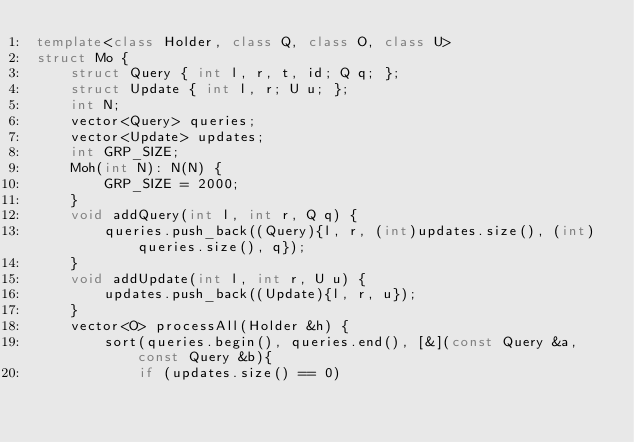Convert code to text. <code><loc_0><loc_0><loc_500><loc_500><_C++_>template<class Holder, class Q, class O, class U>
struct Mo {
    struct Query { int l, r, t, id; Q q; };
    struct Update { int l, r; U u; };
    int N;
    vector<Query> queries;
    vector<Update> updates;
    int GRP_SIZE;
    Moh(int N): N(N) {
        GRP_SIZE = 2000;
    }
    void addQuery(int l, int r, Q q) {
        queries.push_back((Query){l, r, (int)updates.size(), (int)queries.size(), q});
    }
    void addUpdate(int l, int r, U u) {
        updates.push_back((Update){l, r, u});
    }
    vector<O> processAll(Holder &h) {
        sort(queries.begin(), queries.end(), [&](const Query &a, const Query &b){
            if (updates.size() == 0)</code> 